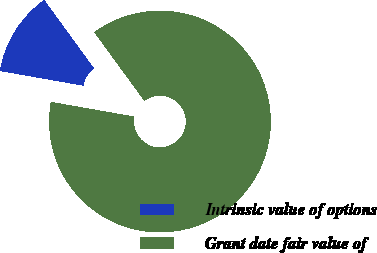Convert chart. <chart><loc_0><loc_0><loc_500><loc_500><pie_chart><fcel>Intrinsic value of options<fcel>Grant date fair value of<nl><fcel>12.2%<fcel>87.8%<nl></chart> 